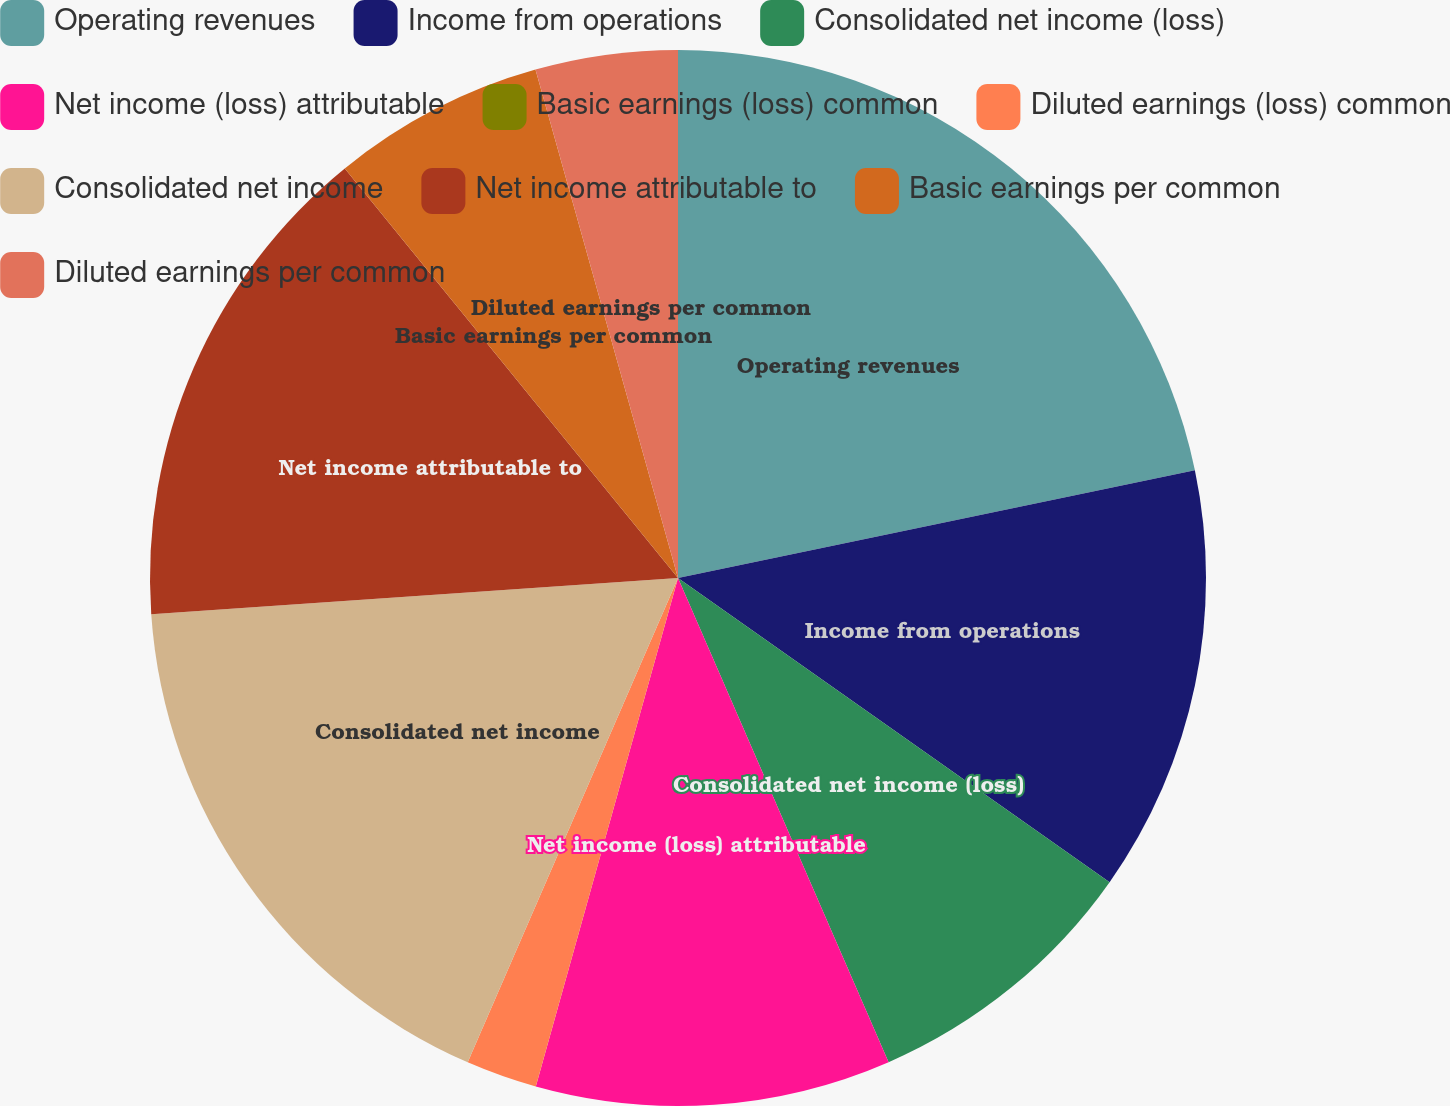Convert chart. <chart><loc_0><loc_0><loc_500><loc_500><pie_chart><fcel>Operating revenues<fcel>Income from operations<fcel>Consolidated net income (loss)<fcel>Net income (loss) attributable<fcel>Basic earnings (loss) common<fcel>Diluted earnings (loss) common<fcel>Consolidated net income<fcel>Net income attributable to<fcel>Basic earnings per common<fcel>Diluted earnings per common<nl><fcel>21.73%<fcel>13.04%<fcel>8.7%<fcel>10.87%<fcel>0.0%<fcel>2.18%<fcel>17.39%<fcel>15.22%<fcel>6.52%<fcel>4.35%<nl></chart> 